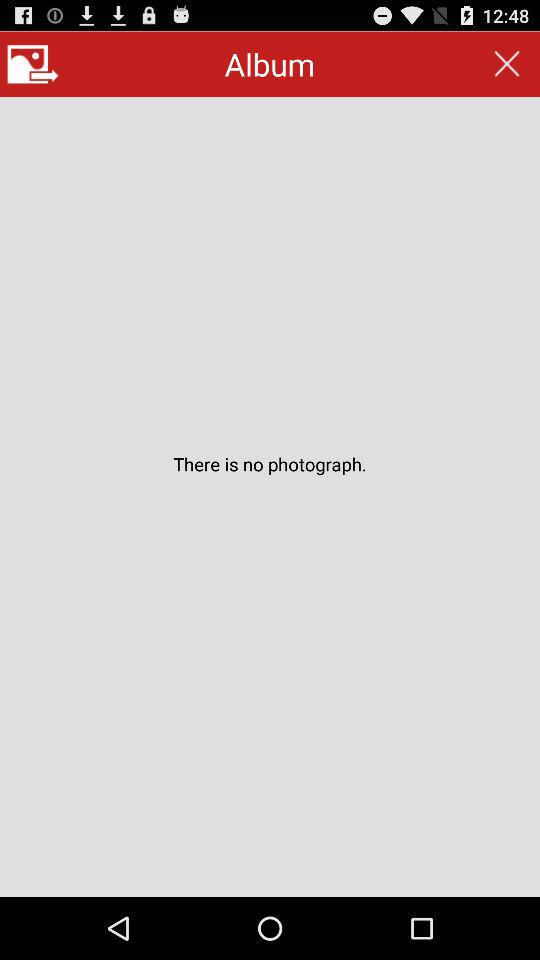How many photographs are there? There are no photographs. 